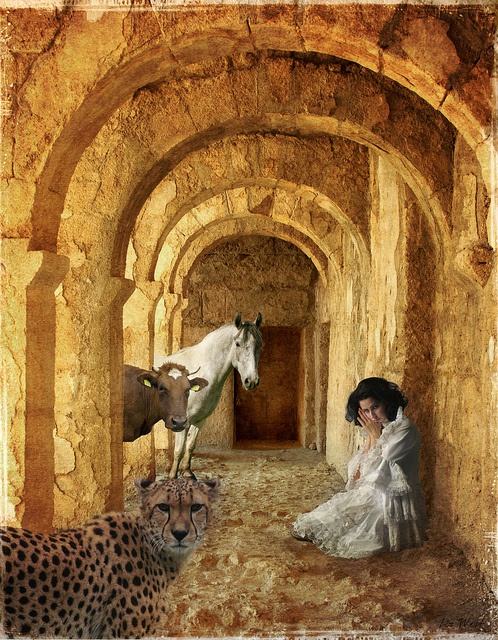Describe the objects in this image and their specific colors. I can see people in khaki, darkgray, black, and gray tones, horse in khaki, tan, beige, darkgreen, and black tones, and cow in khaki, maroon, black, and gray tones in this image. 